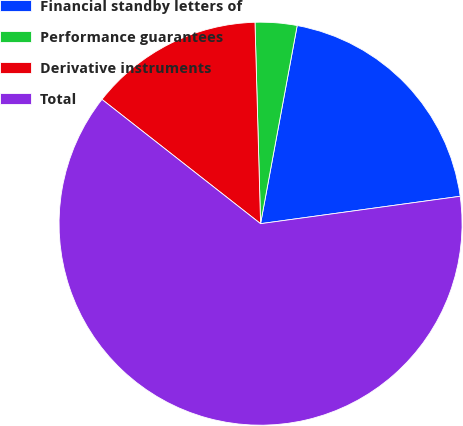<chart> <loc_0><loc_0><loc_500><loc_500><pie_chart><fcel>Financial standby letters of<fcel>Performance guarantees<fcel>Derivative instruments<fcel>Total<nl><fcel>19.92%<fcel>3.35%<fcel>13.98%<fcel>62.75%<nl></chart> 